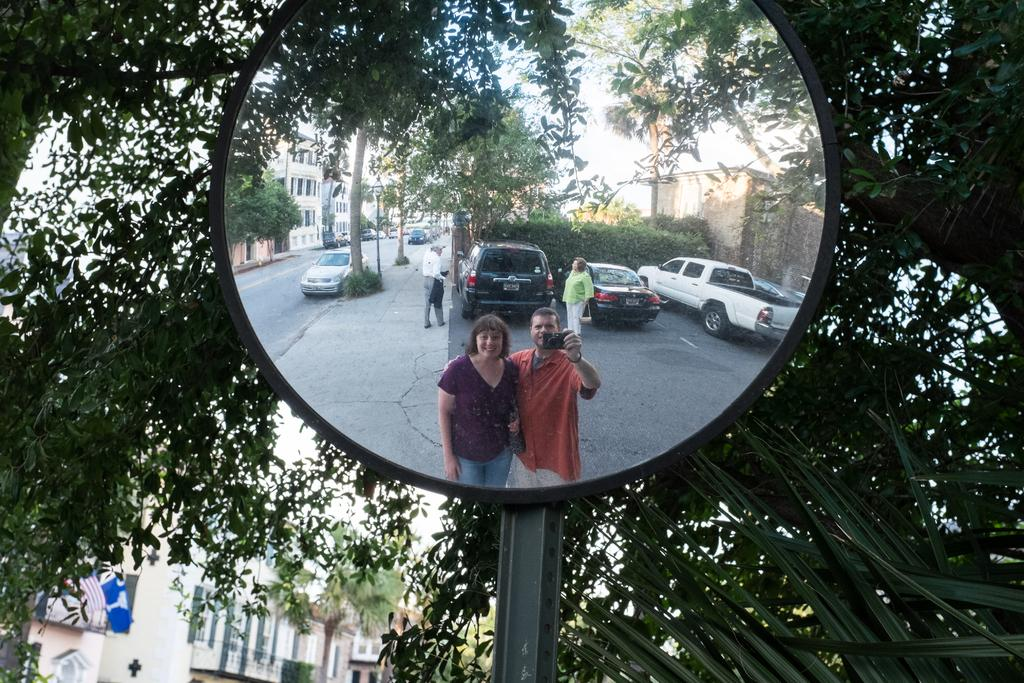What is the main object in the middle of the image? There is a mirror in the middle of the image. What does the mirror reflect in the image? The mirror reflects vehicles, poles, buildings, and a group of people. What can be seen in the background of the image? There are trees visible in the background of the image. What type of pest can be seen crawling on the mirror in the image? There are no pests visible on the mirror in the image. 